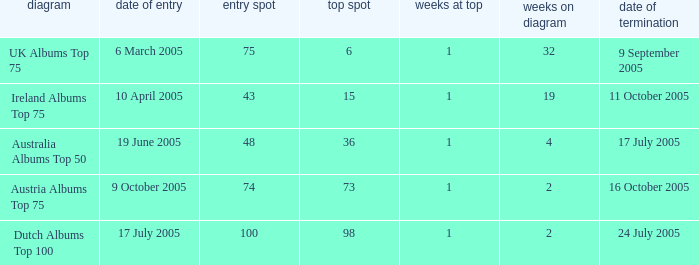What was the total number of weeks on peak for the Ireland Albums Top 75 chart? 1.0. 